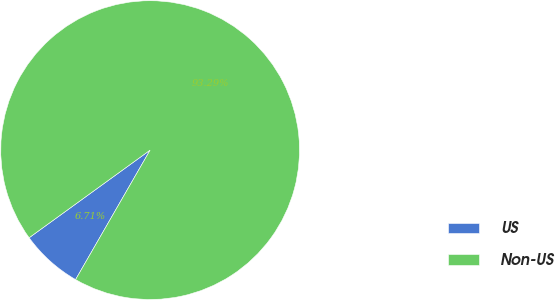Convert chart to OTSL. <chart><loc_0><loc_0><loc_500><loc_500><pie_chart><fcel>US<fcel>Non-US<nl><fcel>6.71%<fcel>93.29%<nl></chart> 